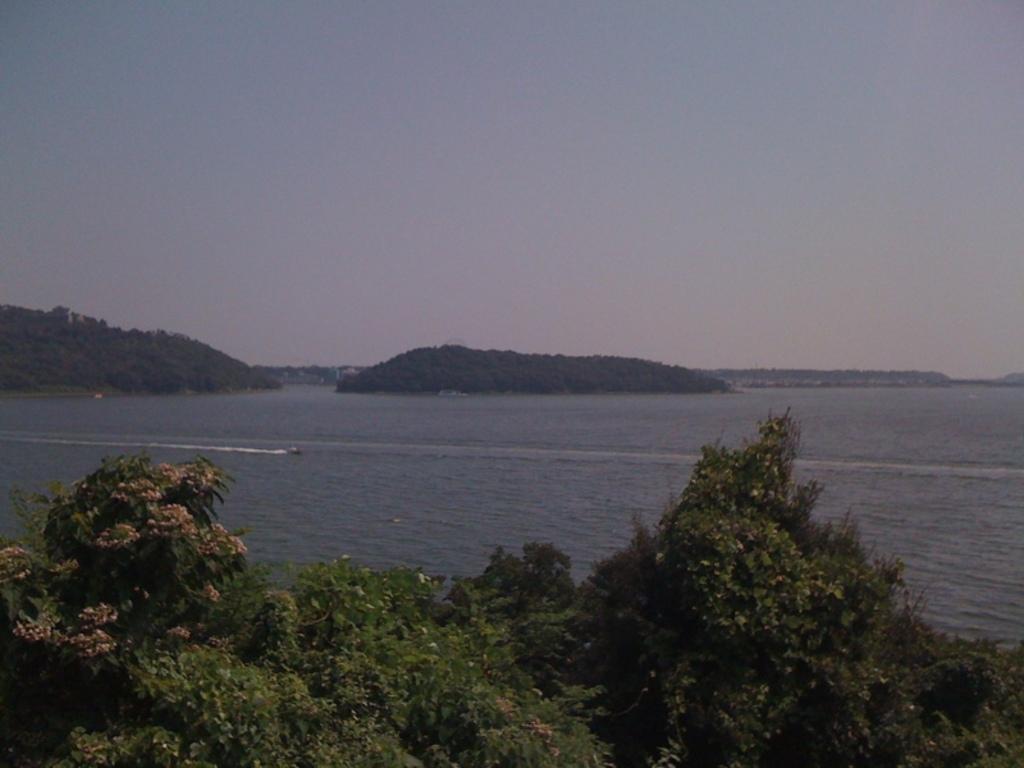In one or two sentences, can you explain what this image depicts? In the picture we can see some plants with some flowers to it and behind it we can see water and far from it we can see hills and sky. 